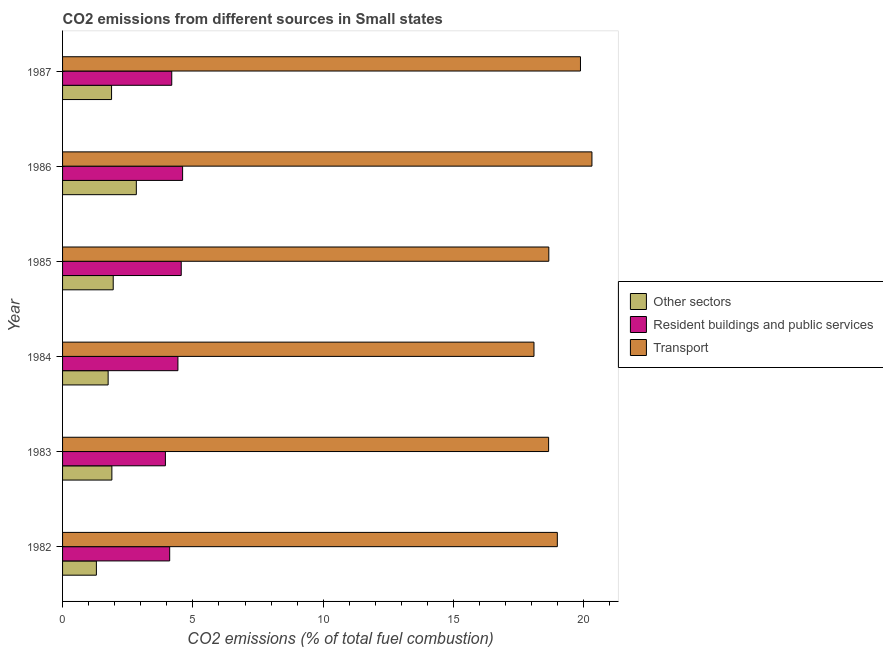Are the number of bars on each tick of the Y-axis equal?
Keep it short and to the point. Yes. How many bars are there on the 3rd tick from the top?
Your answer should be very brief. 3. What is the label of the 5th group of bars from the top?
Your answer should be very brief. 1983. In how many cases, is the number of bars for a given year not equal to the number of legend labels?
Offer a terse response. 0. What is the percentage of co2 emissions from other sectors in 1982?
Provide a succinct answer. 1.3. Across all years, what is the maximum percentage of co2 emissions from transport?
Ensure brevity in your answer.  20.31. Across all years, what is the minimum percentage of co2 emissions from other sectors?
Provide a succinct answer. 1.3. In which year was the percentage of co2 emissions from other sectors minimum?
Your answer should be compact. 1982. What is the total percentage of co2 emissions from other sectors in the graph?
Offer a terse response. 11.59. What is the difference between the percentage of co2 emissions from other sectors in 1984 and that in 1986?
Give a very brief answer. -1.08. What is the difference between the percentage of co2 emissions from other sectors in 1983 and the percentage of co2 emissions from resident buildings and public services in 1987?
Your answer should be very brief. -2.3. What is the average percentage of co2 emissions from transport per year?
Provide a short and direct response. 19.09. In the year 1985, what is the difference between the percentage of co2 emissions from transport and percentage of co2 emissions from other sectors?
Offer a terse response. 16.71. In how many years, is the percentage of co2 emissions from resident buildings and public services greater than 6 %?
Keep it short and to the point. 0. What is the ratio of the percentage of co2 emissions from resident buildings and public services in 1982 to that in 1984?
Make the answer very short. 0.93. What is the difference between the highest and the second highest percentage of co2 emissions from other sectors?
Your answer should be compact. 0.89. What is the difference between the highest and the lowest percentage of co2 emissions from resident buildings and public services?
Your answer should be very brief. 0.66. Is the sum of the percentage of co2 emissions from other sectors in 1983 and 1987 greater than the maximum percentage of co2 emissions from resident buildings and public services across all years?
Offer a very short reply. No. What does the 2nd bar from the top in 1983 represents?
Keep it short and to the point. Resident buildings and public services. What does the 3rd bar from the bottom in 1986 represents?
Keep it short and to the point. Transport. What is the difference between two consecutive major ticks on the X-axis?
Keep it short and to the point. 5. Does the graph contain grids?
Your response must be concise. No. How many legend labels are there?
Your answer should be very brief. 3. What is the title of the graph?
Provide a short and direct response. CO2 emissions from different sources in Small states. Does "Secondary" appear as one of the legend labels in the graph?
Ensure brevity in your answer.  No. What is the label or title of the X-axis?
Provide a succinct answer. CO2 emissions (% of total fuel combustion). What is the CO2 emissions (% of total fuel combustion) in Other sectors in 1982?
Your answer should be very brief. 1.3. What is the CO2 emissions (% of total fuel combustion) of Resident buildings and public services in 1982?
Ensure brevity in your answer.  4.11. What is the CO2 emissions (% of total fuel combustion) in Transport in 1982?
Give a very brief answer. 18.98. What is the CO2 emissions (% of total fuel combustion) of Other sectors in 1983?
Give a very brief answer. 1.89. What is the CO2 emissions (% of total fuel combustion) of Resident buildings and public services in 1983?
Offer a terse response. 3.95. What is the CO2 emissions (% of total fuel combustion) in Transport in 1983?
Give a very brief answer. 18.65. What is the CO2 emissions (% of total fuel combustion) in Other sectors in 1984?
Ensure brevity in your answer.  1.75. What is the CO2 emissions (% of total fuel combustion) in Resident buildings and public services in 1984?
Make the answer very short. 4.43. What is the CO2 emissions (% of total fuel combustion) in Transport in 1984?
Your answer should be very brief. 18.09. What is the CO2 emissions (% of total fuel combustion) of Other sectors in 1985?
Ensure brevity in your answer.  1.94. What is the CO2 emissions (% of total fuel combustion) of Resident buildings and public services in 1985?
Your answer should be compact. 4.55. What is the CO2 emissions (% of total fuel combustion) in Transport in 1985?
Offer a very short reply. 18.66. What is the CO2 emissions (% of total fuel combustion) of Other sectors in 1986?
Provide a short and direct response. 2.83. What is the CO2 emissions (% of total fuel combustion) of Resident buildings and public services in 1986?
Offer a terse response. 4.61. What is the CO2 emissions (% of total fuel combustion) in Transport in 1986?
Provide a succinct answer. 20.31. What is the CO2 emissions (% of total fuel combustion) in Other sectors in 1987?
Provide a short and direct response. 1.88. What is the CO2 emissions (% of total fuel combustion) in Resident buildings and public services in 1987?
Offer a terse response. 4.19. What is the CO2 emissions (% of total fuel combustion) in Transport in 1987?
Offer a terse response. 19.87. Across all years, what is the maximum CO2 emissions (% of total fuel combustion) of Other sectors?
Your answer should be very brief. 2.83. Across all years, what is the maximum CO2 emissions (% of total fuel combustion) of Resident buildings and public services?
Your answer should be compact. 4.61. Across all years, what is the maximum CO2 emissions (% of total fuel combustion) in Transport?
Your answer should be very brief. 20.31. Across all years, what is the minimum CO2 emissions (% of total fuel combustion) in Other sectors?
Give a very brief answer. 1.3. Across all years, what is the minimum CO2 emissions (% of total fuel combustion) of Resident buildings and public services?
Offer a very short reply. 3.95. Across all years, what is the minimum CO2 emissions (% of total fuel combustion) of Transport?
Provide a short and direct response. 18.09. What is the total CO2 emissions (% of total fuel combustion) in Other sectors in the graph?
Your answer should be compact. 11.59. What is the total CO2 emissions (% of total fuel combustion) in Resident buildings and public services in the graph?
Keep it short and to the point. 25.83. What is the total CO2 emissions (% of total fuel combustion) of Transport in the graph?
Give a very brief answer. 114.56. What is the difference between the CO2 emissions (% of total fuel combustion) of Other sectors in 1982 and that in 1983?
Ensure brevity in your answer.  -0.59. What is the difference between the CO2 emissions (% of total fuel combustion) in Resident buildings and public services in 1982 and that in 1983?
Offer a terse response. 0.16. What is the difference between the CO2 emissions (% of total fuel combustion) of Transport in 1982 and that in 1983?
Offer a very short reply. 0.33. What is the difference between the CO2 emissions (% of total fuel combustion) in Other sectors in 1982 and that in 1984?
Offer a terse response. -0.45. What is the difference between the CO2 emissions (% of total fuel combustion) of Resident buildings and public services in 1982 and that in 1984?
Keep it short and to the point. -0.32. What is the difference between the CO2 emissions (% of total fuel combustion) in Transport in 1982 and that in 1984?
Provide a short and direct response. 0.9. What is the difference between the CO2 emissions (% of total fuel combustion) in Other sectors in 1982 and that in 1985?
Keep it short and to the point. -0.65. What is the difference between the CO2 emissions (% of total fuel combustion) in Resident buildings and public services in 1982 and that in 1985?
Your answer should be very brief. -0.44. What is the difference between the CO2 emissions (% of total fuel combustion) in Transport in 1982 and that in 1985?
Provide a succinct answer. 0.33. What is the difference between the CO2 emissions (% of total fuel combustion) in Other sectors in 1982 and that in 1986?
Your answer should be compact. -1.53. What is the difference between the CO2 emissions (% of total fuel combustion) of Resident buildings and public services in 1982 and that in 1986?
Offer a very short reply. -0.5. What is the difference between the CO2 emissions (% of total fuel combustion) in Transport in 1982 and that in 1986?
Ensure brevity in your answer.  -1.33. What is the difference between the CO2 emissions (% of total fuel combustion) in Other sectors in 1982 and that in 1987?
Provide a short and direct response. -0.58. What is the difference between the CO2 emissions (% of total fuel combustion) of Resident buildings and public services in 1982 and that in 1987?
Your answer should be very brief. -0.08. What is the difference between the CO2 emissions (% of total fuel combustion) of Transport in 1982 and that in 1987?
Your response must be concise. -0.89. What is the difference between the CO2 emissions (% of total fuel combustion) in Other sectors in 1983 and that in 1984?
Give a very brief answer. 0.14. What is the difference between the CO2 emissions (% of total fuel combustion) of Resident buildings and public services in 1983 and that in 1984?
Your answer should be compact. -0.48. What is the difference between the CO2 emissions (% of total fuel combustion) in Transport in 1983 and that in 1984?
Ensure brevity in your answer.  0.56. What is the difference between the CO2 emissions (% of total fuel combustion) of Other sectors in 1983 and that in 1985?
Offer a very short reply. -0.05. What is the difference between the CO2 emissions (% of total fuel combustion) of Resident buildings and public services in 1983 and that in 1985?
Offer a terse response. -0.61. What is the difference between the CO2 emissions (% of total fuel combustion) in Transport in 1983 and that in 1985?
Provide a short and direct response. -0.01. What is the difference between the CO2 emissions (% of total fuel combustion) of Other sectors in 1983 and that in 1986?
Your response must be concise. -0.94. What is the difference between the CO2 emissions (% of total fuel combustion) of Resident buildings and public services in 1983 and that in 1986?
Your answer should be very brief. -0.66. What is the difference between the CO2 emissions (% of total fuel combustion) of Transport in 1983 and that in 1986?
Offer a very short reply. -1.66. What is the difference between the CO2 emissions (% of total fuel combustion) in Other sectors in 1983 and that in 1987?
Offer a very short reply. 0.01. What is the difference between the CO2 emissions (% of total fuel combustion) of Resident buildings and public services in 1983 and that in 1987?
Provide a succinct answer. -0.24. What is the difference between the CO2 emissions (% of total fuel combustion) of Transport in 1983 and that in 1987?
Offer a terse response. -1.22. What is the difference between the CO2 emissions (% of total fuel combustion) of Other sectors in 1984 and that in 1985?
Keep it short and to the point. -0.19. What is the difference between the CO2 emissions (% of total fuel combustion) of Resident buildings and public services in 1984 and that in 1985?
Your answer should be compact. -0.13. What is the difference between the CO2 emissions (% of total fuel combustion) in Transport in 1984 and that in 1985?
Keep it short and to the point. -0.57. What is the difference between the CO2 emissions (% of total fuel combustion) of Other sectors in 1984 and that in 1986?
Keep it short and to the point. -1.08. What is the difference between the CO2 emissions (% of total fuel combustion) in Resident buildings and public services in 1984 and that in 1986?
Offer a terse response. -0.18. What is the difference between the CO2 emissions (% of total fuel combustion) in Transport in 1984 and that in 1986?
Ensure brevity in your answer.  -2.22. What is the difference between the CO2 emissions (% of total fuel combustion) in Other sectors in 1984 and that in 1987?
Provide a short and direct response. -0.13. What is the difference between the CO2 emissions (% of total fuel combustion) in Resident buildings and public services in 1984 and that in 1987?
Provide a succinct answer. 0.24. What is the difference between the CO2 emissions (% of total fuel combustion) of Transport in 1984 and that in 1987?
Provide a succinct answer. -1.78. What is the difference between the CO2 emissions (% of total fuel combustion) in Other sectors in 1985 and that in 1986?
Make the answer very short. -0.89. What is the difference between the CO2 emissions (% of total fuel combustion) of Resident buildings and public services in 1985 and that in 1986?
Ensure brevity in your answer.  -0.05. What is the difference between the CO2 emissions (% of total fuel combustion) of Transport in 1985 and that in 1986?
Offer a very short reply. -1.65. What is the difference between the CO2 emissions (% of total fuel combustion) in Other sectors in 1985 and that in 1987?
Your answer should be compact. 0.06. What is the difference between the CO2 emissions (% of total fuel combustion) in Resident buildings and public services in 1985 and that in 1987?
Ensure brevity in your answer.  0.36. What is the difference between the CO2 emissions (% of total fuel combustion) in Transport in 1985 and that in 1987?
Provide a short and direct response. -1.21. What is the difference between the CO2 emissions (% of total fuel combustion) in Other sectors in 1986 and that in 1987?
Provide a short and direct response. 0.95. What is the difference between the CO2 emissions (% of total fuel combustion) in Resident buildings and public services in 1986 and that in 1987?
Keep it short and to the point. 0.42. What is the difference between the CO2 emissions (% of total fuel combustion) in Transport in 1986 and that in 1987?
Your response must be concise. 0.44. What is the difference between the CO2 emissions (% of total fuel combustion) of Other sectors in 1982 and the CO2 emissions (% of total fuel combustion) of Resident buildings and public services in 1983?
Offer a terse response. -2.65. What is the difference between the CO2 emissions (% of total fuel combustion) in Other sectors in 1982 and the CO2 emissions (% of total fuel combustion) in Transport in 1983?
Provide a succinct answer. -17.35. What is the difference between the CO2 emissions (% of total fuel combustion) of Resident buildings and public services in 1982 and the CO2 emissions (% of total fuel combustion) of Transport in 1983?
Your answer should be very brief. -14.54. What is the difference between the CO2 emissions (% of total fuel combustion) in Other sectors in 1982 and the CO2 emissions (% of total fuel combustion) in Resident buildings and public services in 1984?
Keep it short and to the point. -3.13. What is the difference between the CO2 emissions (% of total fuel combustion) in Other sectors in 1982 and the CO2 emissions (% of total fuel combustion) in Transport in 1984?
Provide a short and direct response. -16.79. What is the difference between the CO2 emissions (% of total fuel combustion) in Resident buildings and public services in 1982 and the CO2 emissions (% of total fuel combustion) in Transport in 1984?
Provide a short and direct response. -13.98. What is the difference between the CO2 emissions (% of total fuel combustion) of Other sectors in 1982 and the CO2 emissions (% of total fuel combustion) of Resident buildings and public services in 1985?
Offer a very short reply. -3.25. What is the difference between the CO2 emissions (% of total fuel combustion) of Other sectors in 1982 and the CO2 emissions (% of total fuel combustion) of Transport in 1985?
Make the answer very short. -17.36. What is the difference between the CO2 emissions (% of total fuel combustion) in Resident buildings and public services in 1982 and the CO2 emissions (% of total fuel combustion) in Transport in 1985?
Offer a very short reply. -14.55. What is the difference between the CO2 emissions (% of total fuel combustion) of Other sectors in 1982 and the CO2 emissions (% of total fuel combustion) of Resident buildings and public services in 1986?
Make the answer very short. -3.31. What is the difference between the CO2 emissions (% of total fuel combustion) of Other sectors in 1982 and the CO2 emissions (% of total fuel combustion) of Transport in 1986?
Keep it short and to the point. -19.01. What is the difference between the CO2 emissions (% of total fuel combustion) in Resident buildings and public services in 1982 and the CO2 emissions (% of total fuel combustion) in Transport in 1986?
Keep it short and to the point. -16.2. What is the difference between the CO2 emissions (% of total fuel combustion) in Other sectors in 1982 and the CO2 emissions (% of total fuel combustion) in Resident buildings and public services in 1987?
Give a very brief answer. -2.89. What is the difference between the CO2 emissions (% of total fuel combustion) in Other sectors in 1982 and the CO2 emissions (% of total fuel combustion) in Transport in 1987?
Provide a short and direct response. -18.57. What is the difference between the CO2 emissions (% of total fuel combustion) of Resident buildings and public services in 1982 and the CO2 emissions (% of total fuel combustion) of Transport in 1987?
Your response must be concise. -15.76. What is the difference between the CO2 emissions (% of total fuel combustion) of Other sectors in 1983 and the CO2 emissions (% of total fuel combustion) of Resident buildings and public services in 1984?
Your response must be concise. -2.53. What is the difference between the CO2 emissions (% of total fuel combustion) of Other sectors in 1983 and the CO2 emissions (% of total fuel combustion) of Transport in 1984?
Offer a very short reply. -16.2. What is the difference between the CO2 emissions (% of total fuel combustion) of Resident buildings and public services in 1983 and the CO2 emissions (% of total fuel combustion) of Transport in 1984?
Make the answer very short. -14.14. What is the difference between the CO2 emissions (% of total fuel combustion) in Other sectors in 1983 and the CO2 emissions (% of total fuel combustion) in Resident buildings and public services in 1985?
Give a very brief answer. -2.66. What is the difference between the CO2 emissions (% of total fuel combustion) in Other sectors in 1983 and the CO2 emissions (% of total fuel combustion) in Transport in 1985?
Your answer should be compact. -16.76. What is the difference between the CO2 emissions (% of total fuel combustion) in Resident buildings and public services in 1983 and the CO2 emissions (% of total fuel combustion) in Transport in 1985?
Give a very brief answer. -14.71. What is the difference between the CO2 emissions (% of total fuel combustion) in Other sectors in 1983 and the CO2 emissions (% of total fuel combustion) in Resident buildings and public services in 1986?
Give a very brief answer. -2.71. What is the difference between the CO2 emissions (% of total fuel combustion) in Other sectors in 1983 and the CO2 emissions (% of total fuel combustion) in Transport in 1986?
Give a very brief answer. -18.42. What is the difference between the CO2 emissions (% of total fuel combustion) of Resident buildings and public services in 1983 and the CO2 emissions (% of total fuel combustion) of Transport in 1986?
Ensure brevity in your answer.  -16.36. What is the difference between the CO2 emissions (% of total fuel combustion) of Other sectors in 1983 and the CO2 emissions (% of total fuel combustion) of Resident buildings and public services in 1987?
Give a very brief answer. -2.3. What is the difference between the CO2 emissions (% of total fuel combustion) of Other sectors in 1983 and the CO2 emissions (% of total fuel combustion) of Transport in 1987?
Keep it short and to the point. -17.98. What is the difference between the CO2 emissions (% of total fuel combustion) of Resident buildings and public services in 1983 and the CO2 emissions (% of total fuel combustion) of Transport in 1987?
Offer a very short reply. -15.93. What is the difference between the CO2 emissions (% of total fuel combustion) of Other sectors in 1984 and the CO2 emissions (% of total fuel combustion) of Resident buildings and public services in 1985?
Your response must be concise. -2.8. What is the difference between the CO2 emissions (% of total fuel combustion) of Other sectors in 1984 and the CO2 emissions (% of total fuel combustion) of Transport in 1985?
Give a very brief answer. -16.91. What is the difference between the CO2 emissions (% of total fuel combustion) in Resident buildings and public services in 1984 and the CO2 emissions (% of total fuel combustion) in Transport in 1985?
Ensure brevity in your answer.  -14.23. What is the difference between the CO2 emissions (% of total fuel combustion) of Other sectors in 1984 and the CO2 emissions (% of total fuel combustion) of Resident buildings and public services in 1986?
Offer a very short reply. -2.86. What is the difference between the CO2 emissions (% of total fuel combustion) of Other sectors in 1984 and the CO2 emissions (% of total fuel combustion) of Transport in 1986?
Offer a very short reply. -18.56. What is the difference between the CO2 emissions (% of total fuel combustion) in Resident buildings and public services in 1984 and the CO2 emissions (% of total fuel combustion) in Transport in 1986?
Your answer should be compact. -15.88. What is the difference between the CO2 emissions (% of total fuel combustion) of Other sectors in 1984 and the CO2 emissions (% of total fuel combustion) of Resident buildings and public services in 1987?
Keep it short and to the point. -2.44. What is the difference between the CO2 emissions (% of total fuel combustion) of Other sectors in 1984 and the CO2 emissions (% of total fuel combustion) of Transport in 1987?
Your response must be concise. -18.12. What is the difference between the CO2 emissions (% of total fuel combustion) in Resident buildings and public services in 1984 and the CO2 emissions (% of total fuel combustion) in Transport in 1987?
Make the answer very short. -15.44. What is the difference between the CO2 emissions (% of total fuel combustion) of Other sectors in 1985 and the CO2 emissions (% of total fuel combustion) of Resident buildings and public services in 1986?
Give a very brief answer. -2.66. What is the difference between the CO2 emissions (% of total fuel combustion) in Other sectors in 1985 and the CO2 emissions (% of total fuel combustion) in Transport in 1986?
Keep it short and to the point. -18.37. What is the difference between the CO2 emissions (% of total fuel combustion) of Resident buildings and public services in 1985 and the CO2 emissions (% of total fuel combustion) of Transport in 1986?
Offer a terse response. -15.76. What is the difference between the CO2 emissions (% of total fuel combustion) in Other sectors in 1985 and the CO2 emissions (% of total fuel combustion) in Resident buildings and public services in 1987?
Offer a terse response. -2.25. What is the difference between the CO2 emissions (% of total fuel combustion) of Other sectors in 1985 and the CO2 emissions (% of total fuel combustion) of Transport in 1987?
Provide a succinct answer. -17.93. What is the difference between the CO2 emissions (% of total fuel combustion) of Resident buildings and public services in 1985 and the CO2 emissions (% of total fuel combustion) of Transport in 1987?
Provide a short and direct response. -15.32. What is the difference between the CO2 emissions (% of total fuel combustion) of Other sectors in 1986 and the CO2 emissions (% of total fuel combustion) of Resident buildings and public services in 1987?
Keep it short and to the point. -1.36. What is the difference between the CO2 emissions (% of total fuel combustion) of Other sectors in 1986 and the CO2 emissions (% of total fuel combustion) of Transport in 1987?
Provide a succinct answer. -17.04. What is the difference between the CO2 emissions (% of total fuel combustion) of Resident buildings and public services in 1986 and the CO2 emissions (% of total fuel combustion) of Transport in 1987?
Ensure brevity in your answer.  -15.27. What is the average CO2 emissions (% of total fuel combustion) in Other sectors per year?
Your answer should be very brief. 1.93. What is the average CO2 emissions (% of total fuel combustion) of Resident buildings and public services per year?
Provide a short and direct response. 4.31. What is the average CO2 emissions (% of total fuel combustion) in Transport per year?
Provide a succinct answer. 19.09. In the year 1982, what is the difference between the CO2 emissions (% of total fuel combustion) of Other sectors and CO2 emissions (% of total fuel combustion) of Resident buildings and public services?
Keep it short and to the point. -2.81. In the year 1982, what is the difference between the CO2 emissions (% of total fuel combustion) in Other sectors and CO2 emissions (% of total fuel combustion) in Transport?
Provide a succinct answer. -17.69. In the year 1982, what is the difference between the CO2 emissions (% of total fuel combustion) in Resident buildings and public services and CO2 emissions (% of total fuel combustion) in Transport?
Provide a short and direct response. -14.87. In the year 1983, what is the difference between the CO2 emissions (% of total fuel combustion) of Other sectors and CO2 emissions (% of total fuel combustion) of Resident buildings and public services?
Offer a very short reply. -2.05. In the year 1983, what is the difference between the CO2 emissions (% of total fuel combustion) in Other sectors and CO2 emissions (% of total fuel combustion) in Transport?
Your answer should be compact. -16.76. In the year 1983, what is the difference between the CO2 emissions (% of total fuel combustion) in Resident buildings and public services and CO2 emissions (% of total fuel combustion) in Transport?
Your answer should be very brief. -14.7. In the year 1984, what is the difference between the CO2 emissions (% of total fuel combustion) of Other sectors and CO2 emissions (% of total fuel combustion) of Resident buildings and public services?
Make the answer very short. -2.68. In the year 1984, what is the difference between the CO2 emissions (% of total fuel combustion) in Other sectors and CO2 emissions (% of total fuel combustion) in Transport?
Give a very brief answer. -16.34. In the year 1984, what is the difference between the CO2 emissions (% of total fuel combustion) in Resident buildings and public services and CO2 emissions (% of total fuel combustion) in Transport?
Give a very brief answer. -13.66. In the year 1985, what is the difference between the CO2 emissions (% of total fuel combustion) in Other sectors and CO2 emissions (% of total fuel combustion) in Resident buildings and public services?
Give a very brief answer. -2.61. In the year 1985, what is the difference between the CO2 emissions (% of total fuel combustion) in Other sectors and CO2 emissions (% of total fuel combustion) in Transport?
Your answer should be compact. -16.71. In the year 1985, what is the difference between the CO2 emissions (% of total fuel combustion) in Resident buildings and public services and CO2 emissions (% of total fuel combustion) in Transport?
Provide a short and direct response. -14.1. In the year 1986, what is the difference between the CO2 emissions (% of total fuel combustion) in Other sectors and CO2 emissions (% of total fuel combustion) in Resident buildings and public services?
Provide a succinct answer. -1.78. In the year 1986, what is the difference between the CO2 emissions (% of total fuel combustion) in Other sectors and CO2 emissions (% of total fuel combustion) in Transport?
Provide a short and direct response. -17.48. In the year 1986, what is the difference between the CO2 emissions (% of total fuel combustion) of Resident buildings and public services and CO2 emissions (% of total fuel combustion) of Transport?
Provide a succinct answer. -15.7. In the year 1987, what is the difference between the CO2 emissions (% of total fuel combustion) of Other sectors and CO2 emissions (% of total fuel combustion) of Resident buildings and public services?
Provide a succinct answer. -2.31. In the year 1987, what is the difference between the CO2 emissions (% of total fuel combustion) in Other sectors and CO2 emissions (% of total fuel combustion) in Transport?
Ensure brevity in your answer.  -17.99. In the year 1987, what is the difference between the CO2 emissions (% of total fuel combustion) of Resident buildings and public services and CO2 emissions (% of total fuel combustion) of Transport?
Make the answer very short. -15.68. What is the ratio of the CO2 emissions (% of total fuel combustion) of Other sectors in 1982 to that in 1983?
Make the answer very short. 0.69. What is the ratio of the CO2 emissions (% of total fuel combustion) in Resident buildings and public services in 1982 to that in 1983?
Make the answer very short. 1.04. What is the ratio of the CO2 emissions (% of total fuel combustion) of Transport in 1982 to that in 1983?
Provide a succinct answer. 1.02. What is the ratio of the CO2 emissions (% of total fuel combustion) in Other sectors in 1982 to that in 1984?
Your answer should be compact. 0.74. What is the ratio of the CO2 emissions (% of total fuel combustion) in Transport in 1982 to that in 1984?
Keep it short and to the point. 1.05. What is the ratio of the CO2 emissions (% of total fuel combustion) in Other sectors in 1982 to that in 1985?
Ensure brevity in your answer.  0.67. What is the ratio of the CO2 emissions (% of total fuel combustion) in Resident buildings and public services in 1982 to that in 1985?
Give a very brief answer. 0.9. What is the ratio of the CO2 emissions (% of total fuel combustion) of Transport in 1982 to that in 1985?
Provide a short and direct response. 1.02. What is the ratio of the CO2 emissions (% of total fuel combustion) of Other sectors in 1982 to that in 1986?
Offer a very short reply. 0.46. What is the ratio of the CO2 emissions (% of total fuel combustion) in Resident buildings and public services in 1982 to that in 1986?
Your response must be concise. 0.89. What is the ratio of the CO2 emissions (% of total fuel combustion) of Transport in 1982 to that in 1986?
Provide a short and direct response. 0.93. What is the ratio of the CO2 emissions (% of total fuel combustion) in Other sectors in 1982 to that in 1987?
Your response must be concise. 0.69. What is the ratio of the CO2 emissions (% of total fuel combustion) of Resident buildings and public services in 1982 to that in 1987?
Give a very brief answer. 0.98. What is the ratio of the CO2 emissions (% of total fuel combustion) in Transport in 1982 to that in 1987?
Make the answer very short. 0.96. What is the ratio of the CO2 emissions (% of total fuel combustion) of Other sectors in 1983 to that in 1984?
Your response must be concise. 1.08. What is the ratio of the CO2 emissions (% of total fuel combustion) in Resident buildings and public services in 1983 to that in 1984?
Your answer should be very brief. 0.89. What is the ratio of the CO2 emissions (% of total fuel combustion) of Transport in 1983 to that in 1984?
Offer a terse response. 1.03. What is the ratio of the CO2 emissions (% of total fuel combustion) of Other sectors in 1983 to that in 1985?
Keep it short and to the point. 0.97. What is the ratio of the CO2 emissions (% of total fuel combustion) in Resident buildings and public services in 1983 to that in 1985?
Ensure brevity in your answer.  0.87. What is the ratio of the CO2 emissions (% of total fuel combustion) in Transport in 1983 to that in 1985?
Provide a short and direct response. 1. What is the ratio of the CO2 emissions (% of total fuel combustion) in Other sectors in 1983 to that in 1986?
Offer a very short reply. 0.67. What is the ratio of the CO2 emissions (% of total fuel combustion) of Resident buildings and public services in 1983 to that in 1986?
Your answer should be compact. 0.86. What is the ratio of the CO2 emissions (% of total fuel combustion) in Transport in 1983 to that in 1986?
Keep it short and to the point. 0.92. What is the ratio of the CO2 emissions (% of total fuel combustion) of Resident buildings and public services in 1983 to that in 1987?
Your answer should be compact. 0.94. What is the ratio of the CO2 emissions (% of total fuel combustion) in Transport in 1983 to that in 1987?
Keep it short and to the point. 0.94. What is the ratio of the CO2 emissions (% of total fuel combustion) of Other sectors in 1984 to that in 1985?
Make the answer very short. 0.9. What is the ratio of the CO2 emissions (% of total fuel combustion) of Resident buildings and public services in 1984 to that in 1985?
Make the answer very short. 0.97. What is the ratio of the CO2 emissions (% of total fuel combustion) of Transport in 1984 to that in 1985?
Provide a succinct answer. 0.97. What is the ratio of the CO2 emissions (% of total fuel combustion) in Other sectors in 1984 to that in 1986?
Offer a very short reply. 0.62. What is the ratio of the CO2 emissions (% of total fuel combustion) of Transport in 1984 to that in 1986?
Offer a terse response. 0.89. What is the ratio of the CO2 emissions (% of total fuel combustion) of Other sectors in 1984 to that in 1987?
Your response must be concise. 0.93. What is the ratio of the CO2 emissions (% of total fuel combustion) in Resident buildings and public services in 1984 to that in 1987?
Offer a terse response. 1.06. What is the ratio of the CO2 emissions (% of total fuel combustion) in Transport in 1984 to that in 1987?
Offer a very short reply. 0.91. What is the ratio of the CO2 emissions (% of total fuel combustion) of Other sectors in 1985 to that in 1986?
Your response must be concise. 0.69. What is the ratio of the CO2 emissions (% of total fuel combustion) of Transport in 1985 to that in 1986?
Offer a terse response. 0.92. What is the ratio of the CO2 emissions (% of total fuel combustion) of Other sectors in 1985 to that in 1987?
Your answer should be very brief. 1.03. What is the ratio of the CO2 emissions (% of total fuel combustion) of Resident buildings and public services in 1985 to that in 1987?
Ensure brevity in your answer.  1.09. What is the ratio of the CO2 emissions (% of total fuel combustion) of Transport in 1985 to that in 1987?
Offer a very short reply. 0.94. What is the ratio of the CO2 emissions (% of total fuel combustion) of Other sectors in 1986 to that in 1987?
Provide a succinct answer. 1.51. What is the ratio of the CO2 emissions (% of total fuel combustion) in Resident buildings and public services in 1986 to that in 1987?
Your response must be concise. 1.1. What is the ratio of the CO2 emissions (% of total fuel combustion) in Transport in 1986 to that in 1987?
Provide a short and direct response. 1.02. What is the difference between the highest and the second highest CO2 emissions (% of total fuel combustion) of Other sectors?
Your answer should be compact. 0.89. What is the difference between the highest and the second highest CO2 emissions (% of total fuel combustion) of Resident buildings and public services?
Ensure brevity in your answer.  0.05. What is the difference between the highest and the second highest CO2 emissions (% of total fuel combustion) of Transport?
Provide a short and direct response. 0.44. What is the difference between the highest and the lowest CO2 emissions (% of total fuel combustion) of Other sectors?
Provide a succinct answer. 1.53. What is the difference between the highest and the lowest CO2 emissions (% of total fuel combustion) in Resident buildings and public services?
Ensure brevity in your answer.  0.66. What is the difference between the highest and the lowest CO2 emissions (% of total fuel combustion) in Transport?
Ensure brevity in your answer.  2.22. 